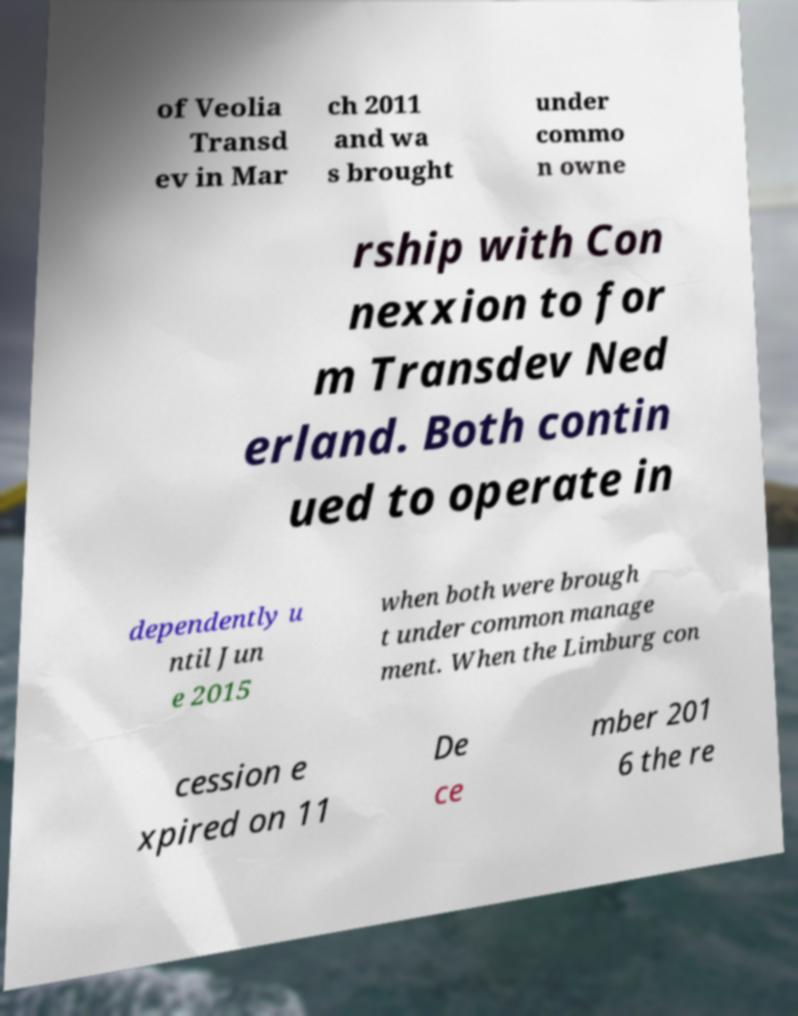What messages or text are displayed in this image? I need them in a readable, typed format. of Veolia Transd ev in Mar ch 2011 and wa s brought under commo n owne rship with Con nexxion to for m Transdev Ned erland. Both contin ued to operate in dependently u ntil Jun e 2015 when both were brough t under common manage ment. When the Limburg con cession e xpired on 11 De ce mber 201 6 the re 